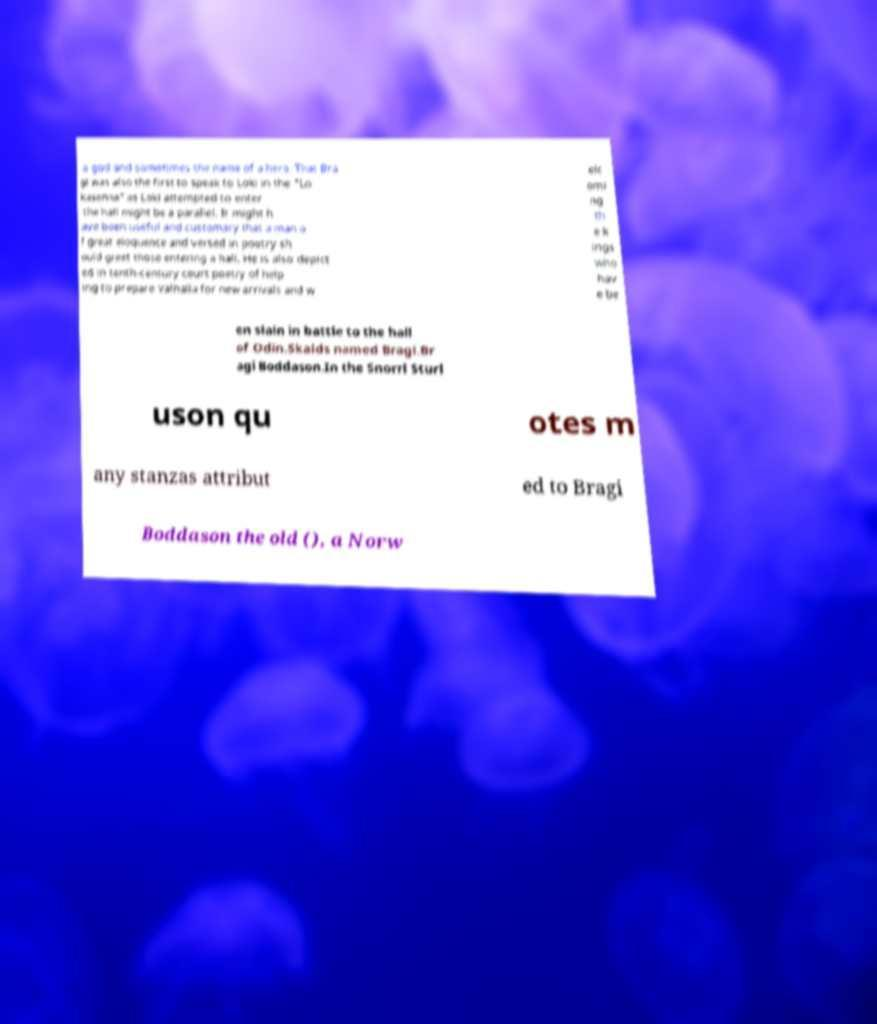There's text embedded in this image that I need extracted. Can you transcribe it verbatim? a god and sometimes the name of a hero. That Bra gi was also the first to speak to Loki in the "Lo kasenna" as Loki attempted to enter the hall might be a parallel. It might h ave been useful and customary that a man o f great eloquence and versed in poetry sh ould greet those entering a hall. He is also depict ed in tenth-century court poetry of help ing to prepare Valhalla for new arrivals and w elc omi ng th e k ings who hav e be en slain in battle to the hall of Odin.Skalds named Bragi.Br agi Boddason.In the Snorri Sturl uson qu otes m any stanzas attribut ed to Bragi Boddason the old (), a Norw 